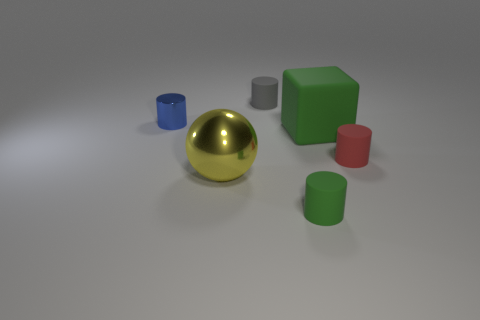Are there fewer small objects in front of the tiny green thing than yellow metallic balls that are left of the green matte cube?
Keep it short and to the point. Yes. What is the color of the tiny metal cylinder?
Provide a short and direct response. Blue. How many small cylinders have the same color as the big block?
Your answer should be very brief. 1. Are there any yellow balls in front of the large green rubber object?
Make the answer very short. Yes. Are there an equal number of matte cubes that are on the left side of the tiny gray object and big green rubber objects in front of the tiny green cylinder?
Your answer should be compact. Yes. There is a metal thing that is behind the tiny red rubber thing; is its size the same as the red thing that is right of the big ball?
Offer a terse response. Yes. What shape is the rubber thing that is behind the tiny cylinder on the left side of the matte cylinder behind the tiny metal thing?
Provide a short and direct response. Cylinder. Is there anything else that is made of the same material as the big sphere?
Ensure brevity in your answer.  Yes. The metallic thing that is the same shape as the tiny gray matte object is what size?
Your response must be concise. Small. There is a rubber cylinder that is behind the large yellow object and on the left side of the large green object; what color is it?
Provide a short and direct response. Gray. 